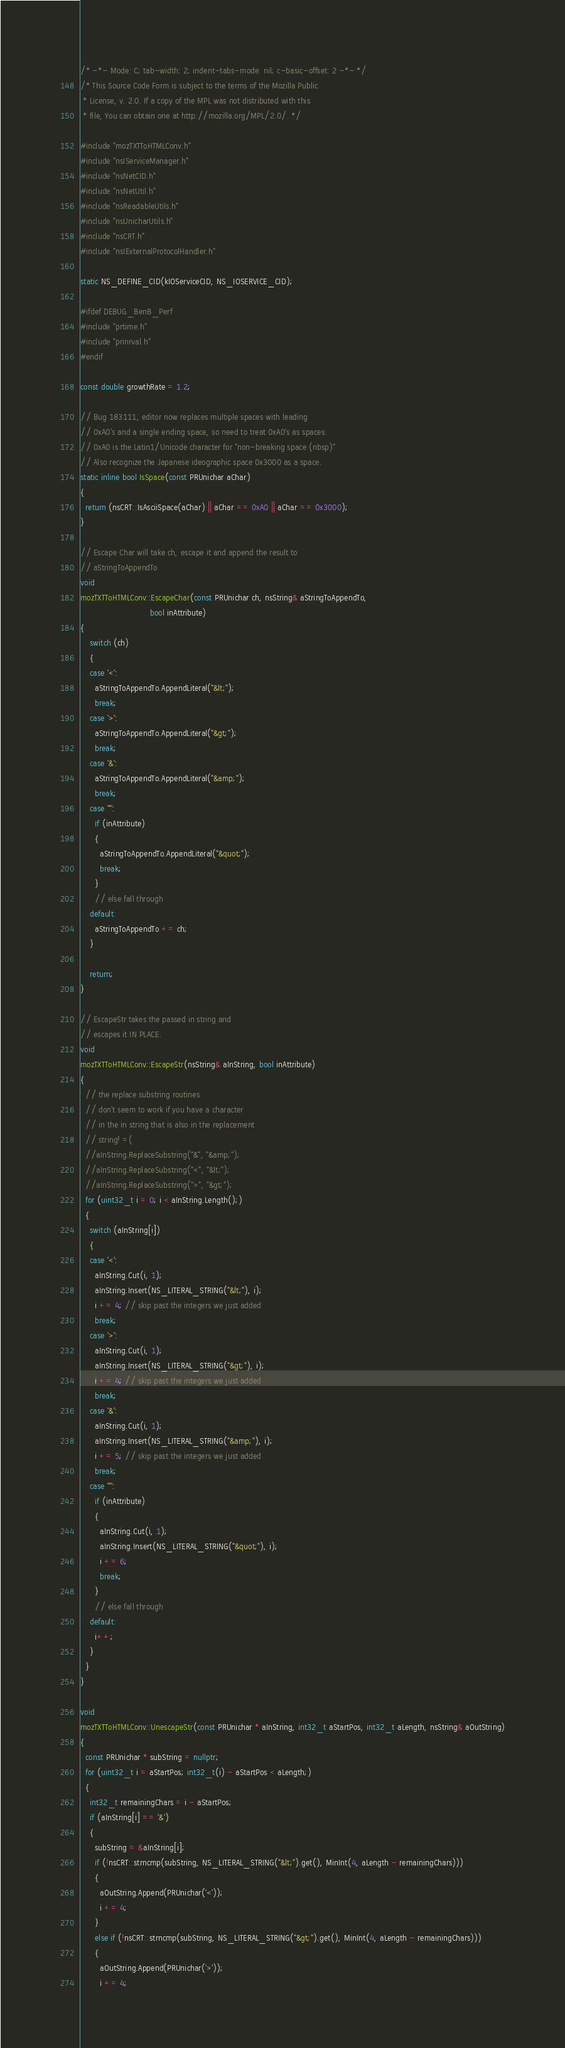Convert code to text. <code><loc_0><loc_0><loc_500><loc_500><_C++_>/* -*- Mode: C; tab-width: 2; indent-tabs-mode: nil; c-basic-offset: 2 -*- */
/* This Source Code Form is subject to the terms of the Mozilla Public
 * License, v. 2.0. If a copy of the MPL was not distributed with this
 * file, You can obtain one at http://mozilla.org/MPL/2.0/. */

#include "mozTXTToHTMLConv.h"
#include "nsIServiceManager.h"
#include "nsNetCID.h"
#include "nsNetUtil.h"
#include "nsReadableUtils.h"
#include "nsUnicharUtils.h"
#include "nsCRT.h"
#include "nsIExternalProtocolHandler.h"

static NS_DEFINE_CID(kIOServiceCID, NS_IOSERVICE_CID);

#ifdef DEBUG_BenB_Perf
#include "prtime.h"
#include "prinrval.h"
#endif

const double growthRate = 1.2;

// Bug 183111, editor now replaces multiple spaces with leading
// 0xA0's and a single ending space, so need to treat 0xA0's as spaces.
// 0xA0 is the Latin1/Unicode character for "non-breaking space (nbsp)"
// Also recognize the Japanese ideographic space 0x3000 as a space.
static inline bool IsSpace(const PRUnichar aChar)
{
  return (nsCRT::IsAsciiSpace(aChar) || aChar == 0xA0 || aChar == 0x3000);
}

// Escape Char will take ch, escape it and append the result to 
// aStringToAppendTo
void
mozTXTToHTMLConv::EscapeChar(const PRUnichar ch, nsString& aStringToAppendTo,
                             bool inAttribute)
{
    switch (ch)
    {
    case '<':
      aStringToAppendTo.AppendLiteral("&lt;");
      break;
    case '>':
      aStringToAppendTo.AppendLiteral("&gt;");
      break;
    case '&':
      aStringToAppendTo.AppendLiteral("&amp;");
      break;
    case '"':
      if (inAttribute)
      {
        aStringToAppendTo.AppendLiteral("&quot;");
        break;
      }
      // else fall through
    default:
      aStringToAppendTo += ch;
    }

    return;
}

// EscapeStr takes the passed in string and
// escapes it IN PLACE.
void
mozTXTToHTMLConv::EscapeStr(nsString& aInString, bool inAttribute)
{
  // the replace substring routines
  // don't seem to work if you have a character
  // in the in string that is also in the replacement
  // string! =(
  //aInString.ReplaceSubstring("&", "&amp;");
  //aInString.ReplaceSubstring("<", "&lt;");
  //aInString.ReplaceSubstring(">", "&gt;");
  for (uint32_t i = 0; i < aInString.Length();)
  {
    switch (aInString[i])
    {
    case '<':
      aInString.Cut(i, 1);
      aInString.Insert(NS_LITERAL_STRING("&lt;"), i);
      i += 4; // skip past the integers we just added
      break;
    case '>':
      aInString.Cut(i, 1);
      aInString.Insert(NS_LITERAL_STRING("&gt;"), i);
      i += 4; // skip past the integers we just added
      break;
    case '&':
      aInString.Cut(i, 1);
      aInString.Insert(NS_LITERAL_STRING("&amp;"), i);
      i += 5; // skip past the integers we just added
      break;
    case '"':
      if (inAttribute)
      {
        aInString.Cut(i, 1);
        aInString.Insert(NS_LITERAL_STRING("&quot;"), i);
        i += 6;
        break;
      }
      // else fall through
    default:
      i++;
    }
  }
}

void 
mozTXTToHTMLConv::UnescapeStr(const PRUnichar * aInString, int32_t aStartPos, int32_t aLength, nsString& aOutString)
{
  const PRUnichar * subString = nullptr;
  for (uint32_t i = aStartPos; int32_t(i) - aStartPos < aLength;)
  {
    int32_t remainingChars = i - aStartPos;
    if (aInString[i] == '&')
    {
      subString = &aInString[i];
      if (!nsCRT::strncmp(subString, NS_LITERAL_STRING("&lt;").get(), MinInt(4, aLength - remainingChars)))
      {
        aOutString.Append(PRUnichar('<'));
        i += 4;
      }
      else if (!nsCRT::strncmp(subString, NS_LITERAL_STRING("&gt;").get(), MinInt(4, aLength - remainingChars)))
      {
        aOutString.Append(PRUnichar('>'));
        i += 4;</code> 